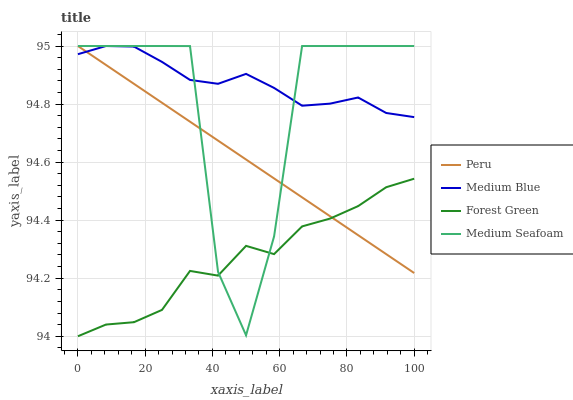Does Forest Green have the minimum area under the curve?
Answer yes or no. Yes. Does Medium Blue have the maximum area under the curve?
Answer yes or no. Yes. Does Medium Seafoam have the minimum area under the curve?
Answer yes or no. No. Does Medium Seafoam have the maximum area under the curve?
Answer yes or no. No. Is Peru the smoothest?
Answer yes or no. Yes. Is Medium Seafoam the roughest?
Answer yes or no. Yes. Is Medium Blue the smoothest?
Answer yes or no. No. Is Medium Blue the roughest?
Answer yes or no. No. Does Medium Seafoam have the lowest value?
Answer yes or no. No. Does Peru have the highest value?
Answer yes or no. Yes. Is Forest Green less than Medium Blue?
Answer yes or no. Yes. Is Medium Blue greater than Forest Green?
Answer yes or no. Yes. Does Medium Blue intersect Peru?
Answer yes or no. Yes. Is Medium Blue less than Peru?
Answer yes or no. No. Is Medium Blue greater than Peru?
Answer yes or no. No. Does Forest Green intersect Medium Blue?
Answer yes or no. No. 